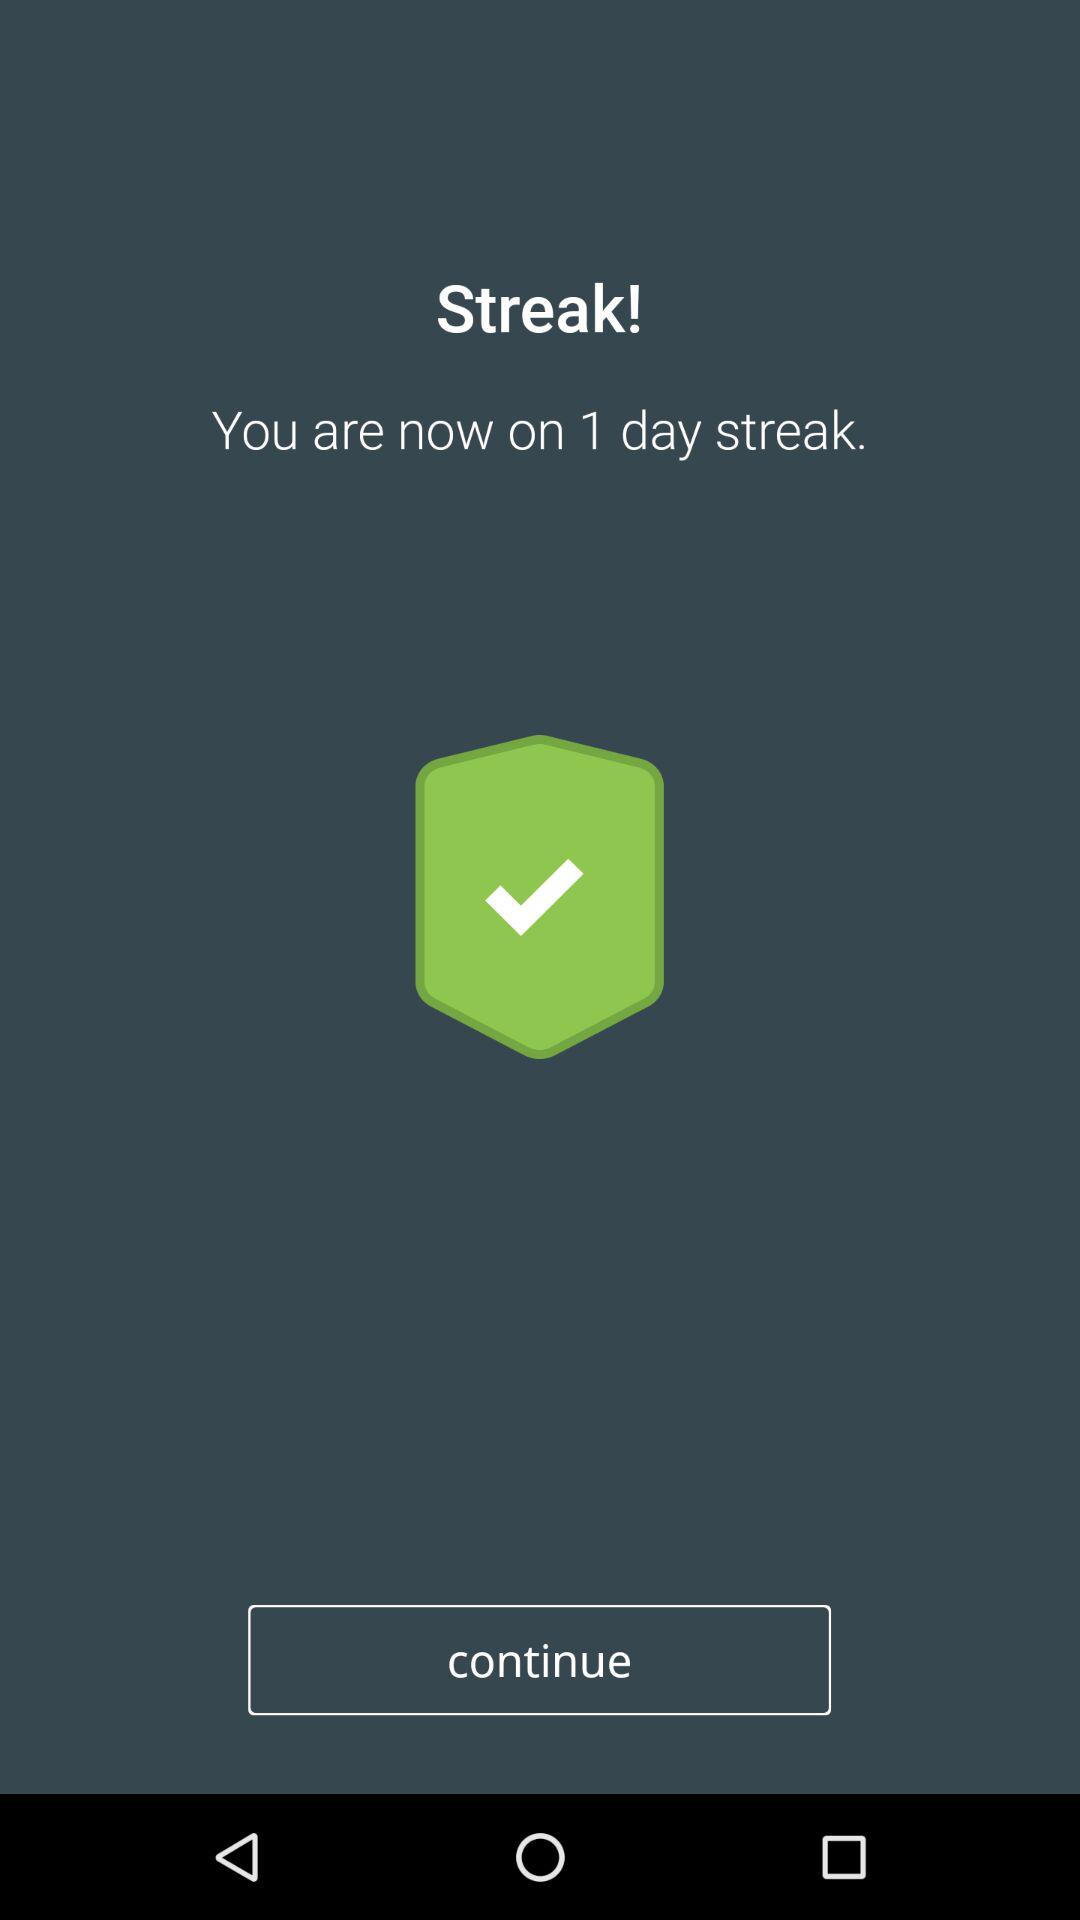How many more days does the user need to reach a 7 day streak?
Answer the question using a single word or phrase. 6 